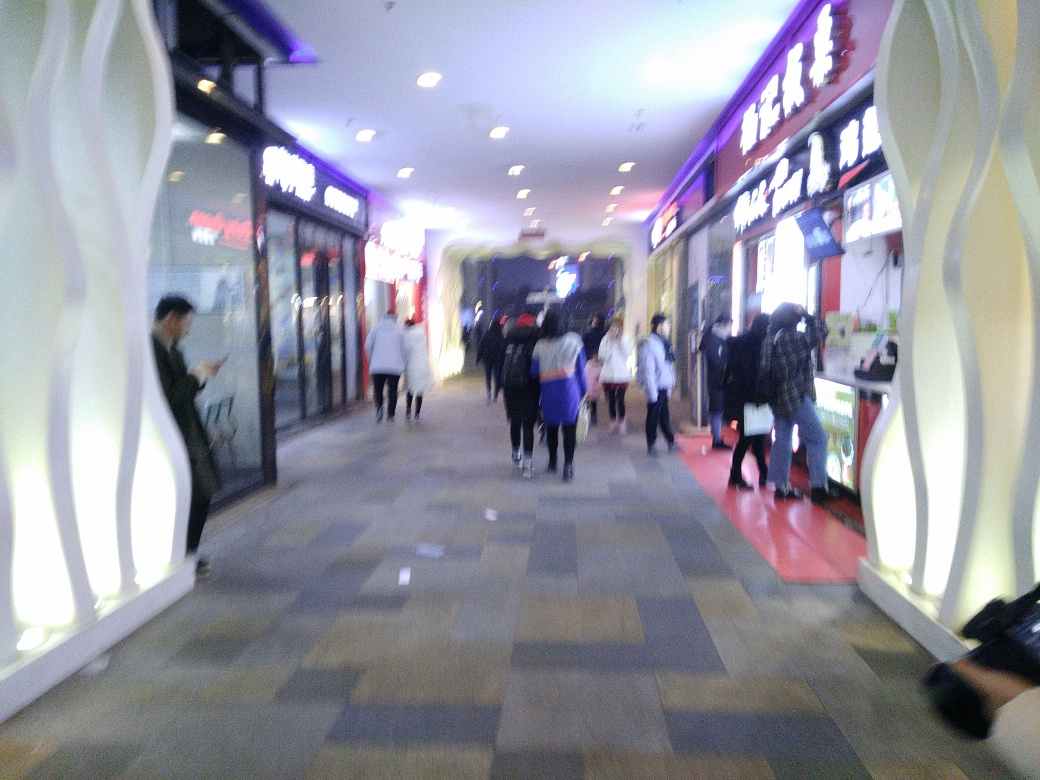What can you infer about the atmosphere or vibe of the place? Although the image is not clear, it suggests a busy and dynamic environment with multiple people in motion, likely indicative of a popular public space with high foot traffic. 